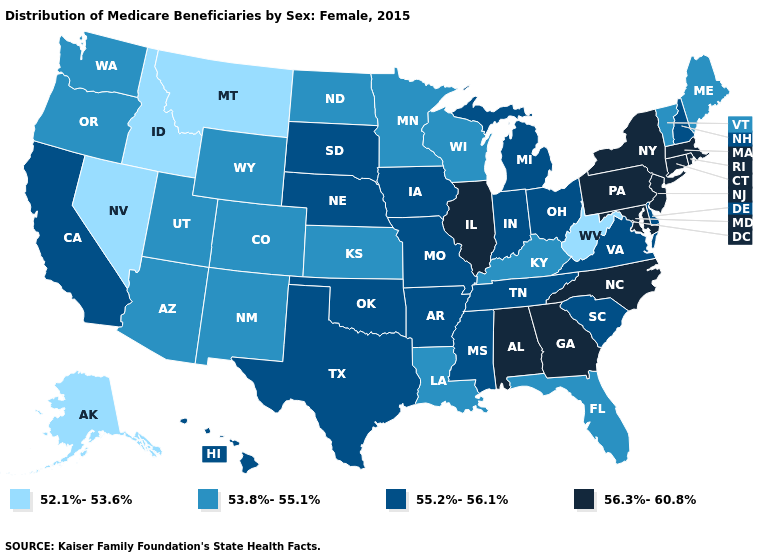What is the highest value in states that border Arizona?
Short answer required. 55.2%-56.1%. Does the map have missing data?
Keep it brief. No. What is the value of North Dakota?
Be succinct. 53.8%-55.1%. Among the states that border North Dakota , does Montana have the lowest value?
Answer briefly. Yes. Name the states that have a value in the range 53.8%-55.1%?
Concise answer only. Arizona, Colorado, Florida, Kansas, Kentucky, Louisiana, Maine, Minnesota, New Mexico, North Dakota, Oregon, Utah, Vermont, Washington, Wisconsin, Wyoming. Name the states that have a value in the range 55.2%-56.1%?
Short answer required. Arkansas, California, Delaware, Hawaii, Indiana, Iowa, Michigan, Mississippi, Missouri, Nebraska, New Hampshire, Ohio, Oklahoma, South Carolina, South Dakota, Tennessee, Texas, Virginia. What is the lowest value in states that border Minnesota?
Quick response, please. 53.8%-55.1%. Which states have the lowest value in the Northeast?
Be succinct. Maine, Vermont. Name the states that have a value in the range 53.8%-55.1%?
Short answer required. Arizona, Colorado, Florida, Kansas, Kentucky, Louisiana, Maine, Minnesota, New Mexico, North Dakota, Oregon, Utah, Vermont, Washington, Wisconsin, Wyoming. Name the states that have a value in the range 56.3%-60.8%?
Concise answer only. Alabama, Connecticut, Georgia, Illinois, Maryland, Massachusetts, New Jersey, New York, North Carolina, Pennsylvania, Rhode Island. Does the first symbol in the legend represent the smallest category?
Concise answer only. Yes. Among the states that border Idaho , which have the lowest value?
Short answer required. Montana, Nevada. What is the highest value in the South ?
Concise answer only. 56.3%-60.8%. Which states have the lowest value in the USA?
Concise answer only. Alaska, Idaho, Montana, Nevada, West Virginia. What is the value of Kansas?
Give a very brief answer. 53.8%-55.1%. 